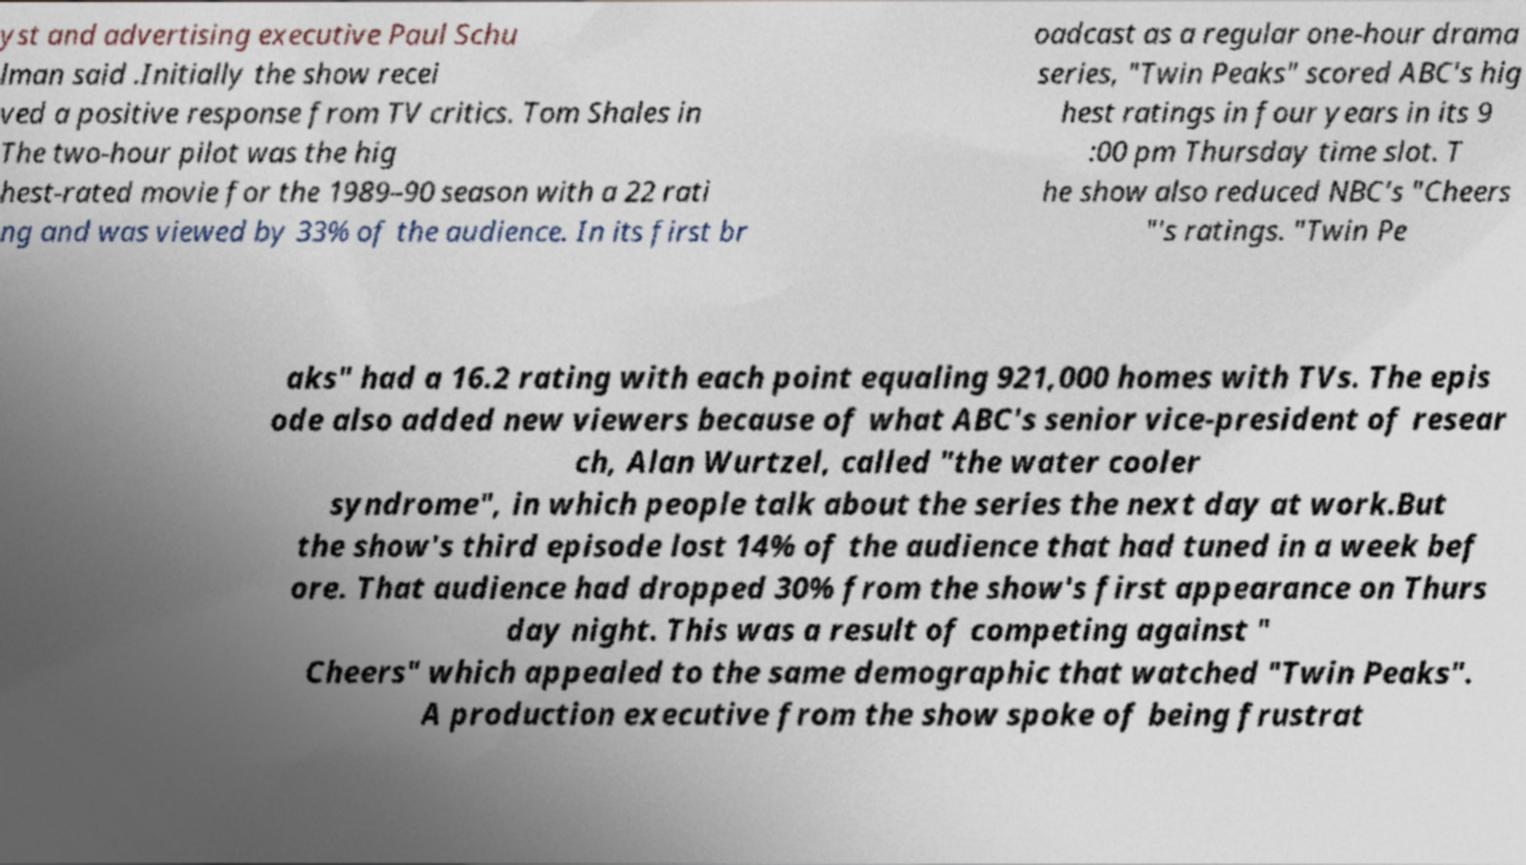Could you extract and type out the text from this image? yst and advertising executive Paul Schu lman said .Initially the show recei ved a positive response from TV critics. Tom Shales in The two-hour pilot was the hig hest-rated movie for the 1989–90 season with a 22 rati ng and was viewed by 33% of the audience. In its first br oadcast as a regular one-hour drama series, "Twin Peaks" scored ABC's hig hest ratings in four years in its 9 :00 pm Thursday time slot. T he show also reduced NBC's "Cheers "'s ratings. "Twin Pe aks" had a 16.2 rating with each point equaling 921,000 homes with TVs. The epis ode also added new viewers because of what ABC's senior vice-president of resear ch, Alan Wurtzel, called "the water cooler syndrome", in which people talk about the series the next day at work.But the show's third episode lost 14% of the audience that had tuned in a week bef ore. That audience had dropped 30% from the show's first appearance on Thurs day night. This was a result of competing against " Cheers" which appealed to the same demographic that watched "Twin Peaks". A production executive from the show spoke of being frustrat 